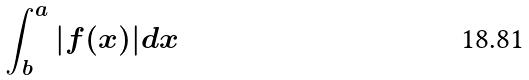<formula> <loc_0><loc_0><loc_500><loc_500>\int _ { b } ^ { a } | f ( x ) | d x</formula> 